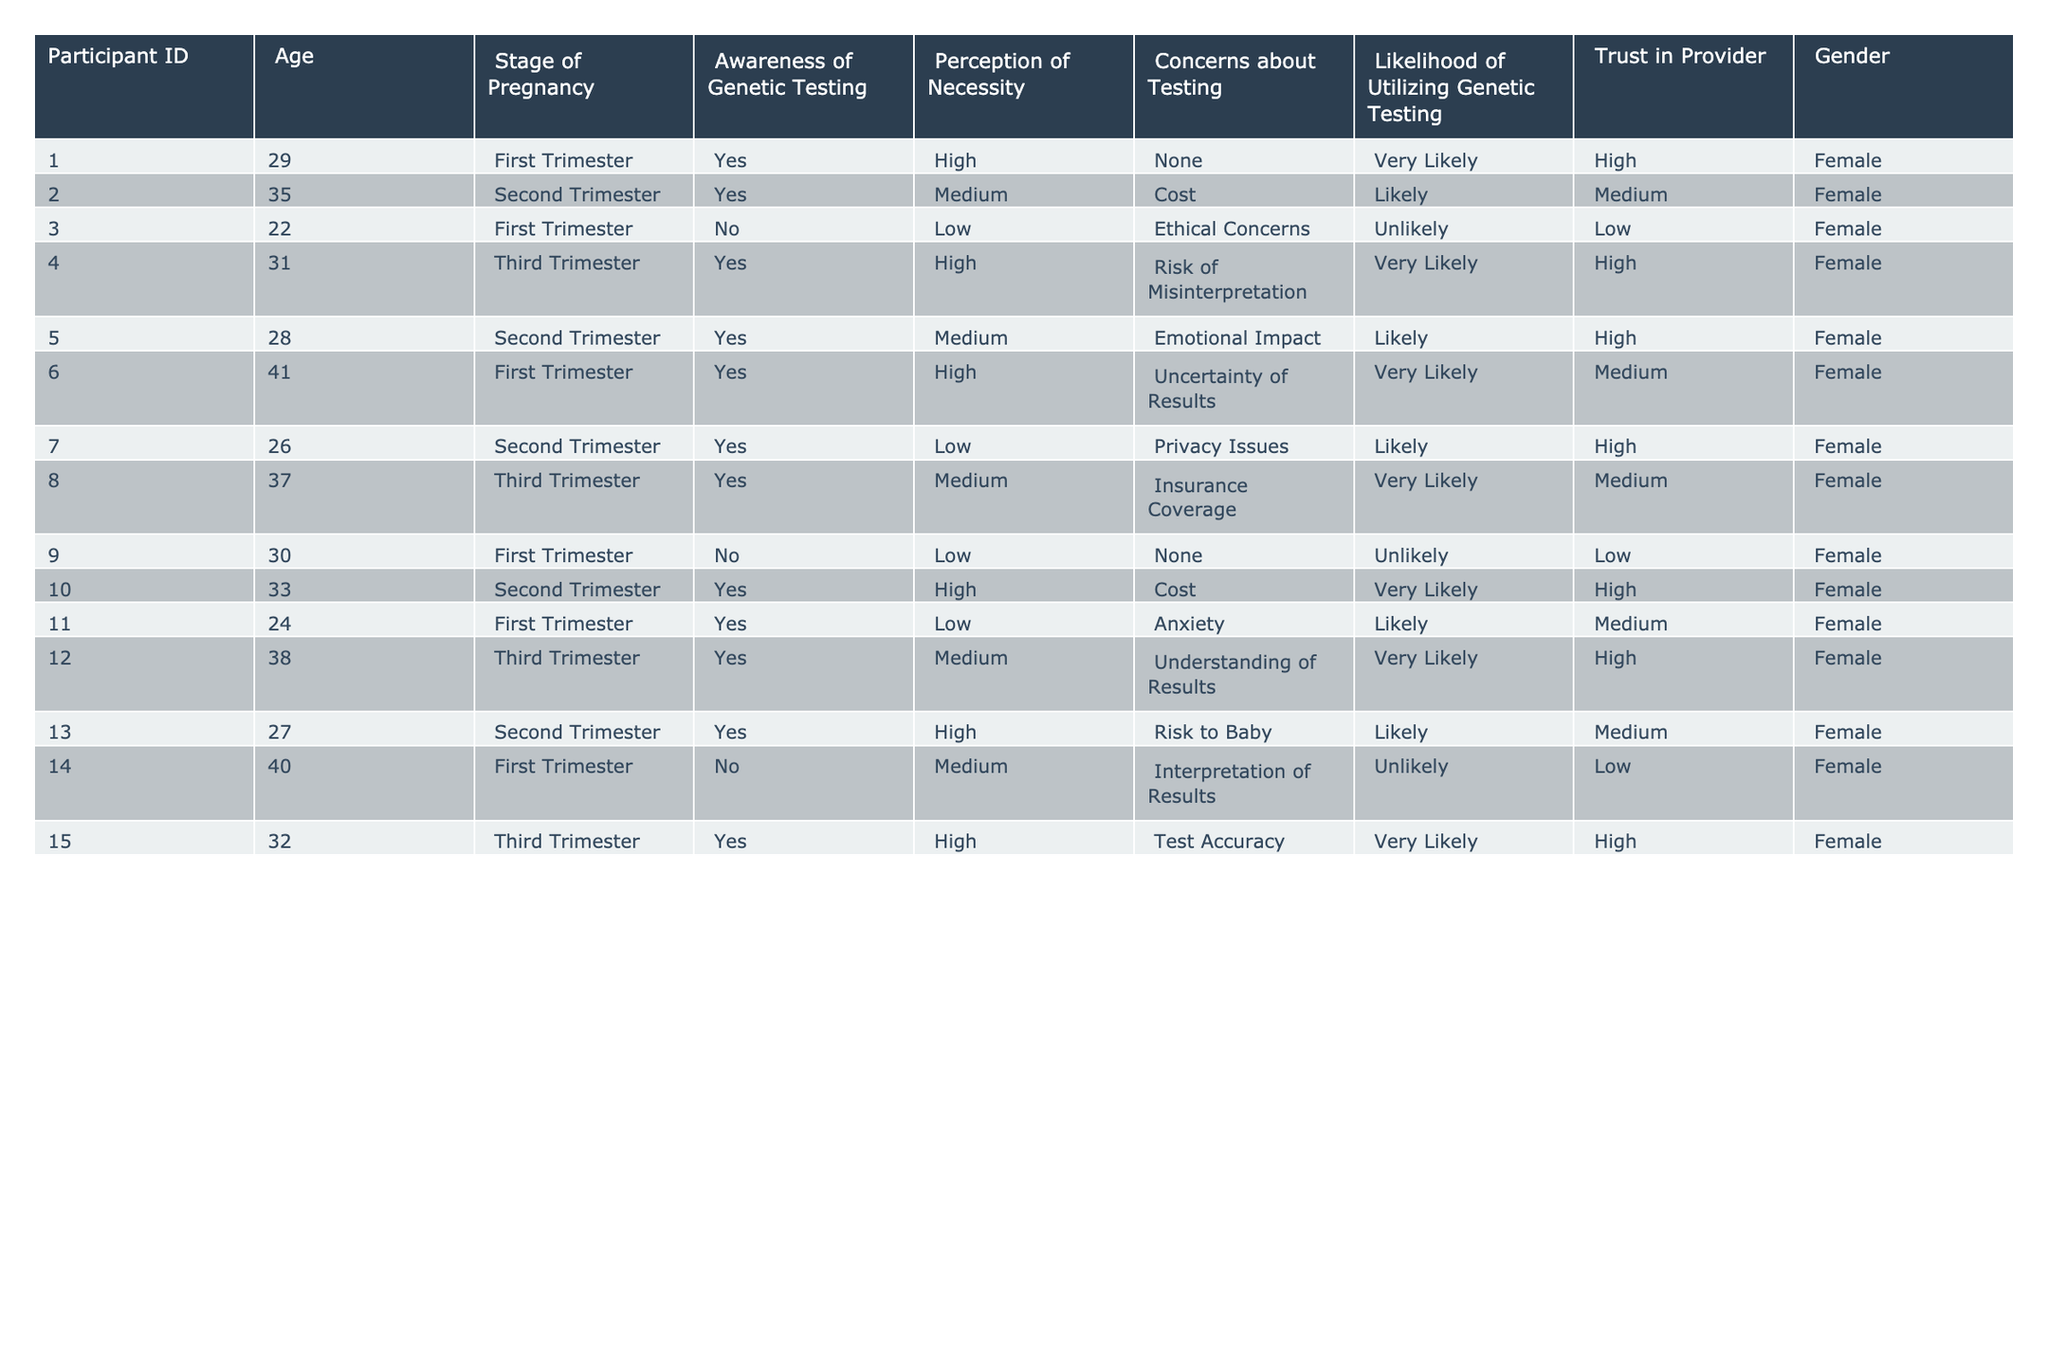What percentage of participants in their first trimester are likely to utilize genetic testing? There are 6 participants in their first trimester (IDs 1, 3, 6, 9, 11, 14). Out of these, 3 (IDs 1, 6, and 11) indicated they are likely or very likely to utilize genetic testing. Therefore, the percentage is (3/6) * 100 = 50%.
Answer: 50% How many participants expressed high trust in their providers? By reviewing the data, we see that there are 5 participants (IDs 1, 4, 10, 12, and 15) who reported high trust in their provider.
Answer: 5 What is the average age of participants who have concerns about insurance coverage? The participant who expressed concerns about insurance coverage is participant IDs 2 and 8. Their ages are 35 and 37 respectively. The average age is (35 + 37) / 2 = 36.
Answer: 36 Is there any participant who is unlikely to utilize genetic testing and has high awareness of it? Reviewing the data reveals that participants IDs 3 and 9 had low likelihood for utilizing genetic testing, but 3 is uncertain (No awareness) while 9 also expressed low awareness. Therefore, the statement can be confirmed as false.
Answer: No What are the most common concerns regarding genetic testing among participants in the second trimester? In the second trimester, the participants (IDs 2, 5, 7, and 13) reported concerns: Cost (2), Emotional Impact (5), Privacy Issues (7), and Risk to Baby (13). The most common concern was Cost and Risk to Baby, appearing once each.
Answer: Cost and Risk to Baby How many participants stated that their perception of necessity for genetic testing was high? The following participants have a high perception of necessity: IDs 1, 4, 6, 10, 12, 13, and 15. This totals to 7 participants.
Answer: 7 Is there a correlation between the stage of pregnancy and the likelihood of utilizing genetic testing among participants? To determine correlation, we can examine patterns in each stage. First trimester: 4 likely, Second trimester: 4 likely; Third trimester: 5 likely. As the stage progresses, likelihood remains relatively high across categories but detailed analysis is needed for statistical correlation. So it appears generally positive but requires deeper evaluation.
Answer: Yes, generally positive but needs analysis Which participant had a medium perception of necessity and concerns about the emotional impact? Participant ID 5 has a medium perception of necessity and concerns about emotional impact related to genetic testing.
Answer: ID 5 What is the total number of participants who expressed concerns regarding test accuracy? Only participant ID 15 expressed concerns regarding test accuracy, so the total number is 1.
Answer: 1 How many participants in the third trimester have a high perception of necessity for genetic testing? The third trimester participants with high perception of necessity are IDs 4, 12, and 15. Hence, there are 3 such participants.
Answer: 3 